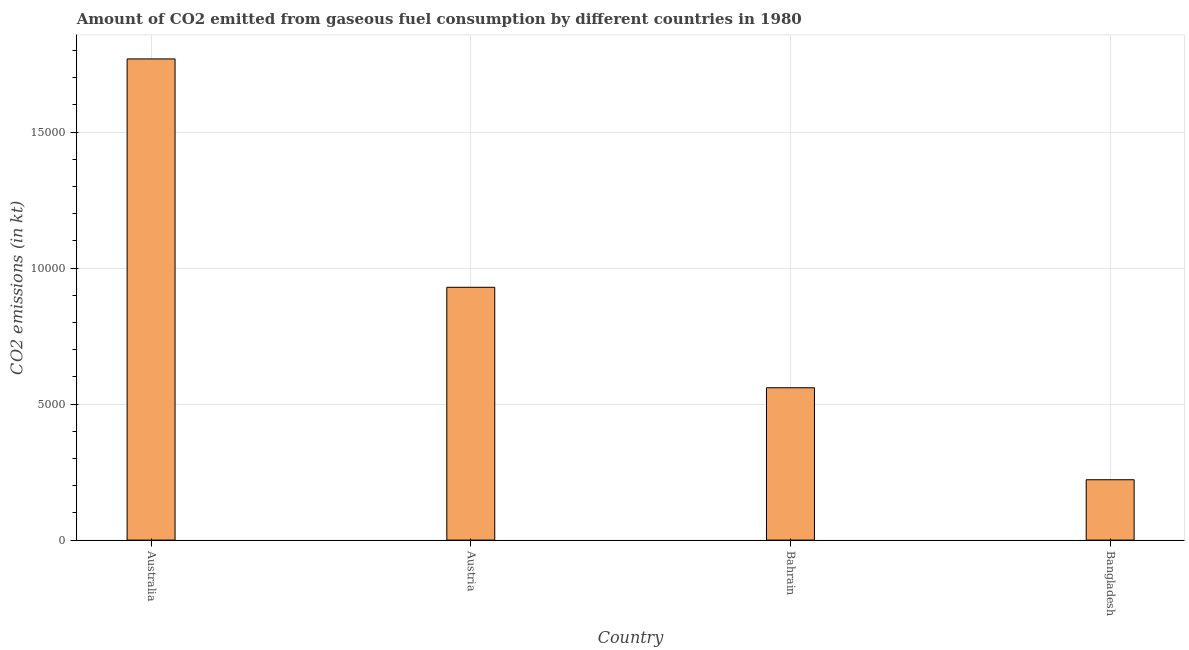Does the graph contain any zero values?
Make the answer very short. No. Does the graph contain grids?
Your answer should be very brief. Yes. What is the title of the graph?
Your answer should be very brief. Amount of CO2 emitted from gaseous fuel consumption by different countries in 1980. What is the label or title of the X-axis?
Your response must be concise. Country. What is the label or title of the Y-axis?
Offer a very short reply. CO2 emissions (in kt). What is the co2 emissions from gaseous fuel consumption in Australia?
Your response must be concise. 1.77e+04. Across all countries, what is the maximum co2 emissions from gaseous fuel consumption?
Give a very brief answer. 1.77e+04. Across all countries, what is the minimum co2 emissions from gaseous fuel consumption?
Your answer should be compact. 2218.53. In which country was the co2 emissions from gaseous fuel consumption minimum?
Provide a succinct answer. Bangladesh. What is the sum of the co2 emissions from gaseous fuel consumption?
Your answer should be very brief. 3.48e+04. What is the difference between the co2 emissions from gaseous fuel consumption in Australia and Bangladesh?
Offer a very short reply. 1.55e+04. What is the average co2 emissions from gaseous fuel consumption per country?
Your answer should be compact. 8699.04. What is the median co2 emissions from gaseous fuel consumption?
Your answer should be very brief. 7445.84. What is the ratio of the co2 emissions from gaseous fuel consumption in Austria to that in Bahrain?
Provide a succinct answer. 1.66. Is the co2 emissions from gaseous fuel consumption in Australia less than that in Bahrain?
Your answer should be very brief. No. What is the difference between the highest and the second highest co2 emissions from gaseous fuel consumption?
Give a very brief answer. 8393.76. Is the sum of the co2 emissions from gaseous fuel consumption in Australia and Bangladesh greater than the maximum co2 emissions from gaseous fuel consumption across all countries?
Ensure brevity in your answer.  Yes. What is the difference between the highest and the lowest co2 emissions from gaseous fuel consumption?
Make the answer very short. 1.55e+04. In how many countries, is the co2 emissions from gaseous fuel consumption greater than the average co2 emissions from gaseous fuel consumption taken over all countries?
Offer a very short reply. 2. How many countries are there in the graph?
Offer a very short reply. 4. Are the values on the major ticks of Y-axis written in scientific E-notation?
Provide a succinct answer. No. What is the CO2 emissions (in kt) of Australia?
Your response must be concise. 1.77e+04. What is the CO2 emissions (in kt) in Austria?
Offer a very short reply. 9292.18. What is the CO2 emissions (in kt) of Bahrain?
Make the answer very short. 5599.51. What is the CO2 emissions (in kt) of Bangladesh?
Keep it short and to the point. 2218.53. What is the difference between the CO2 emissions (in kt) in Australia and Austria?
Keep it short and to the point. 8393.76. What is the difference between the CO2 emissions (in kt) in Australia and Bahrain?
Your answer should be compact. 1.21e+04. What is the difference between the CO2 emissions (in kt) in Australia and Bangladesh?
Make the answer very short. 1.55e+04. What is the difference between the CO2 emissions (in kt) in Austria and Bahrain?
Your answer should be compact. 3692.67. What is the difference between the CO2 emissions (in kt) in Austria and Bangladesh?
Give a very brief answer. 7073.64. What is the difference between the CO2 emissions (in kt) in Bahrain and Bangladesh?
Your answer should be compact. 3380.97. What is the ratio of the CO2 emissions (in kt) in Australia to that in Austria?
Your answer should be very brief. 1.9. What is the ratio of the CO2 emissions (in kt) in Australia to that in Bahrain?
Give a very brief answer. 3.16. What is the ratio of the CO2 emissions (in kt) in Australia to that in Bangladesh?
Your response must be concise. 7.97. What is the ratio of the CO2 emissions (in kt) in Austria to that in Bahrain?
Your answer should be very brief. 1.66. What is the ratio of the CO2 emissions (in kt) in Austria to that in Bangladesh?
Provide a short and direct response. 4.19. What is the ratio of the CO2 emissions (in kt) in Bahrain to that in Bangladesh?
Make the answer very short. 2.52. 